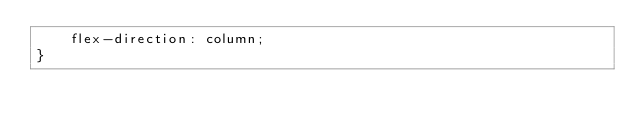<code> <loc_0><loc_0><loc_500><loc_500><_CSS_>    flex-direction: column;
}</code> 